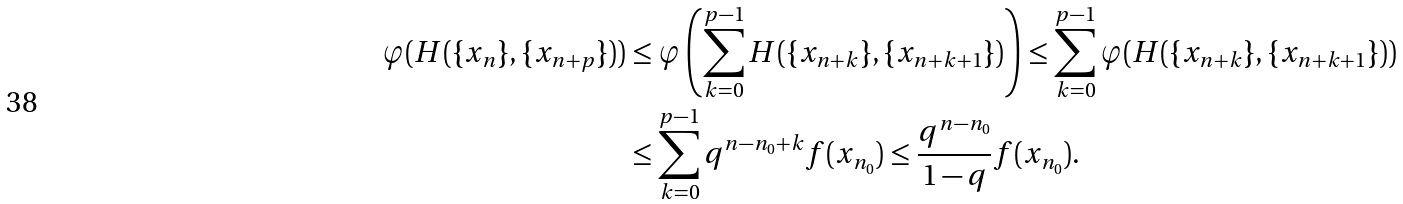<formula> <loc_0><loc_0><loc_500><loc_500>\varphi ( H ( \{ x _ { n } \} , \{ x _ { n + p } \} ) ) & \leq \varphi \left ( \sum _ { k = 0 } ^ { p - 1 } H ( \{ x _ { n + k } \} , \{ x _ { n + k + 1 } \} ) \right ) \leq \sum _ { k = 0 } ^ { p - 1 } \varphi ( H ( \{ x _ { n + k } \} , \{ x _ { n + k + 1 } \} ) ) \\ & \leq \sum _ { k = 0 } ^ { p - 1 } q ^ { n - n _ { 0 } + k } f ( x _ { n _ { 0 } } ) \leq \frac { q ^ { n - n _ { 0 } } } { 1 - q } f ( x _ { n _ { 0 } } ) .</formula> 